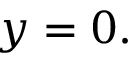Convert formula to latex. <formula><loc_0><loc_0><loc_500><loc_500>y = 0 .</formula> 